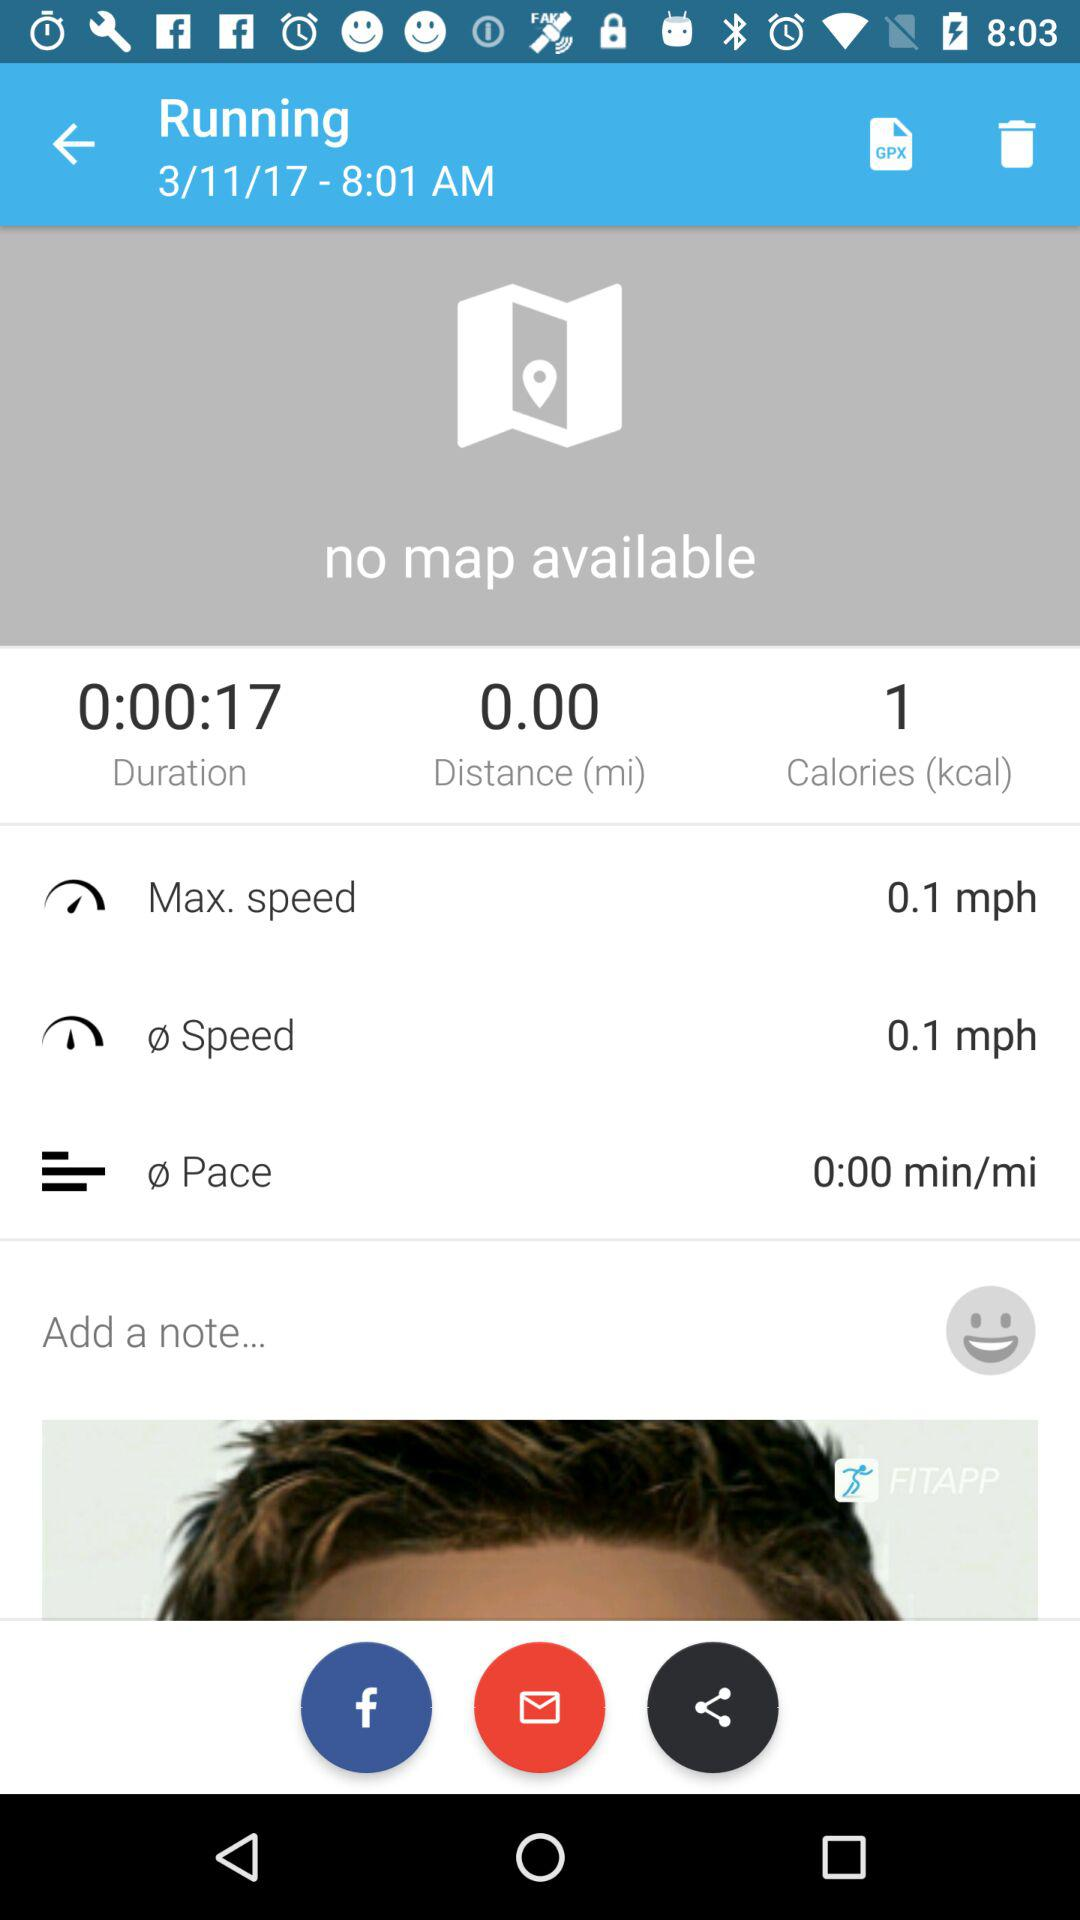What is the unit of speed? The unit of speed is miles per hour. 